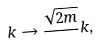Convert formula to latex. <formula><loc_0><loc_0><loc_500><loc_500>k \rightarrow \frac { \sqrt { 2 m } } { } k ,</formula> 